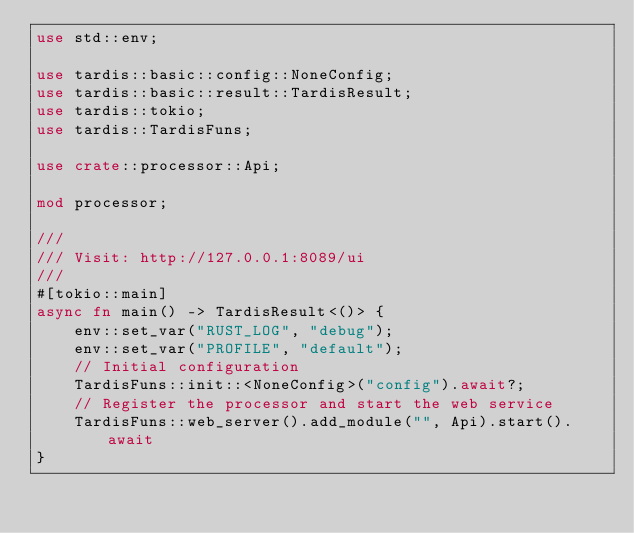Convert code to text. <code><loc_0><loc_0><loc_500><loc_500><_Rust_>use std::env;

use tardis::basic::config::NoneConfig;
use tardis::basic::result::TardisResult;
use tardis::tokio;
use tardis::TardisFuns;

use crate::processor::Api;

mod processor;

///
/// Visit: http://127.0.0.1:8089/ui
///
#[tokio::main]
async fn main() -> TardisResult<()> {
    env::set_var("RUST_LOG", "debug");
    env::set_var("PROFILE", "default");
    // Initial configuration
    TardisFuns::init::<NoneConfig>("config").await?;
    // Register the processor and start the web service
    TardisFuns::web_server().add_module("", Api).start().await
}
</code> 